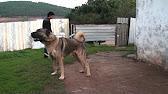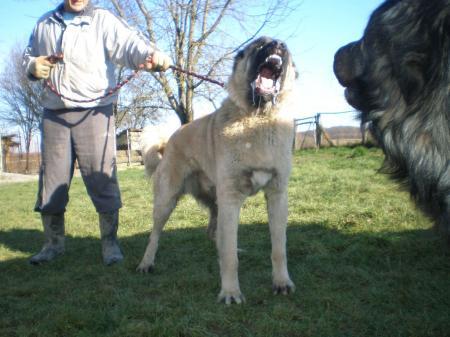The first image is the image on the left, the second image is the image on the right. For the images shown, is this caption "No single image contains more than two dogs, all images show dogs on a grass background, and at least one image includes a familiar collie breed." true? Answer yes or no. No. The first image is the image on the left, the second image is the image on the right. Assess this claim about the two images: "The right image contains exactly two dogs.". Correct or not? Answer yes or no. Yes. 